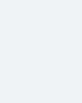Convert code to text. <code><loc_0><loc_0><loc_500><loc_500><_SQL_>
</code> 